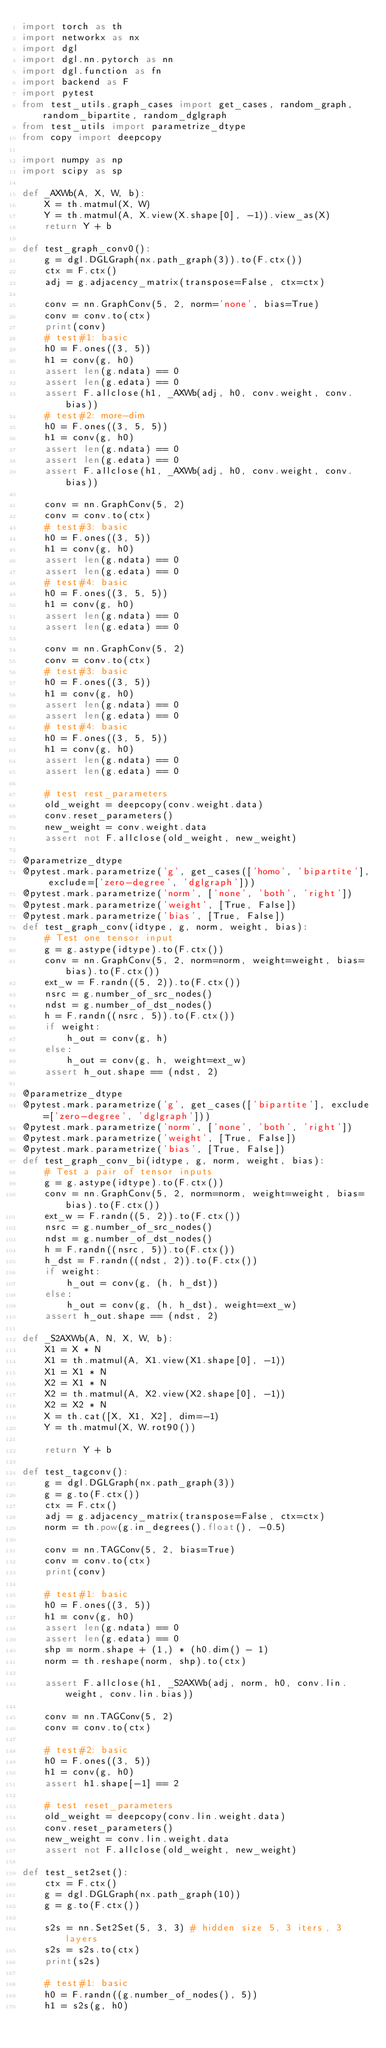<code> <loc_0><loc_0><loc_500><loc_500><_Python_>import torch as th
import networkx as nx
import dgl
import dgl.nn.pytorch as nn
import dgl.function as fn
import backend as F
import pytest
from test_utils.graph_cases import get_cases, random_graph, random_bipartite, random_dglgraph
from test_utils import parametrize_dtype
from copy import deepcopy

import numpy as np
import scipy as sp

def _AXWb(A, X, W, b):
    X = th.matmul(X, W)
    Y = th.matmul(A, X.view(X.shape[0], -1)).view_as(X)
    return Y + b

def test_graph_conv0():
    g = dgl.DGLGraph(nx.path_graph(3)).to(F.ctx())
    ctx = F.ctx()
    adj = g.adjacency_matrix(transpose=False, ctx=ctx)

    conv = nn.GraphConv(5, 2, norm='none', bias=True)
    conv = conv.to(ctx)
    print(conv)
    # test#1: basic
    h0 = F.ones((3, 5))
    h1 = conv(g, h0)
    assert len(g.ndata) == 0
    assert len(g.edata) == 0
    assert F.allclose(h1, _AXWb(adj, h0, conv.weight, conv.bias))
    # test#2: more-dim
    h0 = F.ones((3, 5, 5))
    h1 = conv(g, h0)
    assert len(g.ndata) == 0
    assert len(g.edata) == 0
    assert F.allclose(h1, _AXWb(adj, h0, conv.weight, conv.bias))

    conv = nn.GraphConv(5, 2)
    conv = conv.to(ctx)
    # test#3: basic
    h0 = F.ones((3, 5))
    h1 = conv(g, h0)
    assert len(g.ndata) == 0
    assert len(g.edata) == 0
    # test#4: basic
    h0 = F.ones((3, 5, 5))
    h1 = conv(g, h0)
    assert len(g.ndata) == 0
    assert len(g.edata) == 0

    conv = nn.GraphConv(5, 2)
    conv = conv.to(ctx)
    # test#3: basic
    h0 = F.ones((3, 5))
    h1 = conv(g, h0)
    assert len(g.ndata) == 0
    assert len(g.edata) == 0
    # test#4: basic
    h0 = F.ones((3, 5, 5))
    h1 = conv(g, h0)
    assert len(g.ndata) == 0
    assert len(g.edata) == 0

    # test rest_parameters
    old_weight = deepcopy(conv.weight.data)
    conv.reset_parameters()
    new_weight = conv.weight.data
    assert not F.allclose(old_weight, new_weight)

@parametrize_dtype
@pytest.mark.parametrize('g', get_cases(['homo', 'bipartite'], exclude=['zero-degree', 'dglgraph']))
@pytest.mark.parametrize('norm', ['none', 'both', 'right'])
@pytest.mark.parametrize('weight', [True, False])
@pytest.mark.parametrize('bias', [True, False])
def test_graph_conv(idtype, g, norm, weight, bias):
    # Test one tensor input
    g = g.astype(idtype).to(F.ctx())
    conv = nn.GraphConv(5, 2, norm=norm, weight=weight, bias=bias).to(F.ctx())
    ext_w = F.randn((5, 2)).to(F.ctx())
    nsrc = g.number_of_src_nodes()
    ndst = g.number_of_dst_nodes()
    h = F.randn((nsrc, 5)).to(F.ctx())
    if weight:
        h_out = conv(g, h)
    else:
        h_out = conv(g, h, weight=ext_w)
    assert h_out.shape == (ndst, 2)

@parametrize_dtype
@pytest.mark.parametrize('g', get_cases(['bipartite'], exclude=['zero-degree', 'dglgraph']))
@pytest.mark.parametrize('norm', ['none', 'both', 'right'])
@pytest.mark.parametrize('weight', [True, False])
@pytest.mark.parametrize('bias', [True, False])
def test_graph_conv_bi(idtype, g, norm, weight, bias):
    # Test a pair of tensor inputs
    g = g.astype(idtype).to(F.ctx())
    conv = nn.GraphConv(5, 2, norm=norm, weight=weight, bias=bias).to(F.ctx())
    ext_w = F.randn((5, 2)).to(F.ctx())
    nsrc = g.number_of_src_nodes()
    ndst = g.number_of_dst_nodes()
    h = F.randn((nsrc, 5)).to(F.ctx())
    h_dst = F.randn((ndst, 2)).to(F.ctx())
    if weight:
        h_out = conv(g, (h, h_dst))
    else:
        h_out = conv(g, (h, h_dst), weight=ext_w)
    assert h_out.shape == (ndst, 2)

def _S2AXWb(A, N, X, W, b):
    X1 = X * N
    X1 = th.matmul(A, X1.view(X1.shape[0], -1))
    X1 = X1 * N
    X2 = X1 * N
    X2 = th.matmul(A, X2.view(X2.shape[0], -1))
    X2 = X2 * N
    X = th.cat([X, X1, X2], dim=-1)
    Y = th.matmul(X, W.rot90())

    return Y + b

def test_tagconv():
    g = dgl.DGLGraph(nx.path_graph(3))
    g = g.to(F.ctx())
    ctx = F.ctx()
    adj = g.adjacency_matrix(transpose=False, ctx=ctx)
    norm = th.pow(g.in_degrees().float(), -0.5)

    conv = nn.TAGConv(5, 2, bias=True)
    conv = conv.to(ctx)
    print(conv)

    # test#1: basic
    h0 = F.ones((3, 5))
    h1 = conv(g, h0)
    assert len(g.ndata) == 0
    assert len(g.edata) == 0
    shp = norm.shape + (1,) * (h0.dim() - 1)
    norm = th.reshape(norm, shp).to(ctx)

    assert F.allclose(h1, _S2AXWb(adj, norm, h0, conv.lin.weight, conv.lin.bias))

    conv = nn.TAGConv(5, 2)
    conv = conv.to(ctx)

    # test#2: basic
    h0 = F.ones((3, 5))
    h1 = conv(g, h0)
    assert h1.shape[-1] == 2

    # test reset_parameters
    old_weight = deepcopy(conv.lin.weight.data)
    conv.reset_parameters()
    new_weight = conv.lin.weight.data
    assert not F.allclose(old_weight, new_weight)

def test_set2set():
    ctx = F.ctx()
    g = dgl.DGLGraph(nx.path_graph(10))
    g = g.to(F.ctx())

    s2s = nn.Set2Set(5, 3, 3) # hidden size 5, 3 iters, 3 layers
    s2s = s2s.to(ctx)
    print(s2s)

    # test#1: basic
    h0 = F.randn((g.number_of_nodes(), 5))
    h1 = s2s(g, h0)</code> 